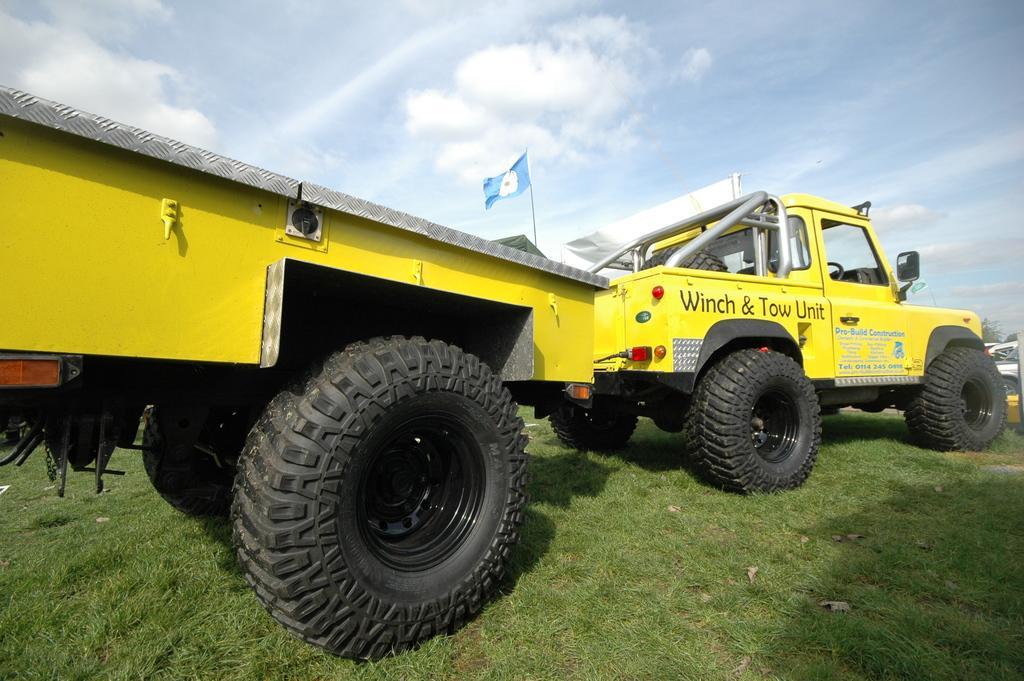Can you describe this image briefly? In this image I see a vehicle, which is yellow in color and it is on the grass and I also see a flag over here. In the background I see the sky. 